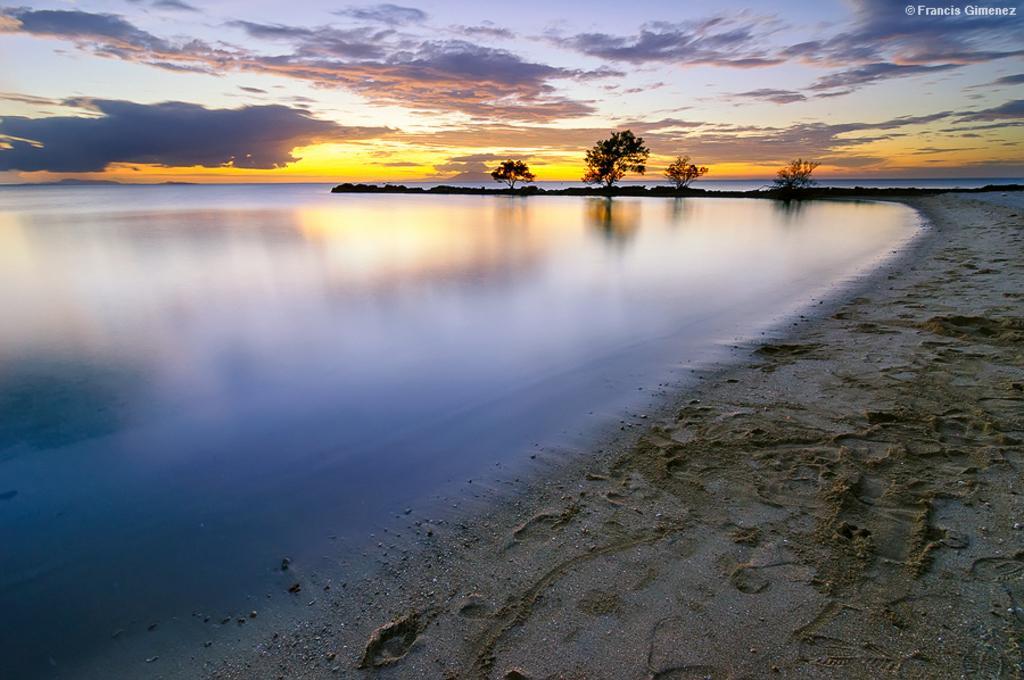Could you give a brief overview of what you see in this image? In this image, I can see trees, sand and water. In the background, there is the sky. At the top right corner of the image, I can see a watermark. 